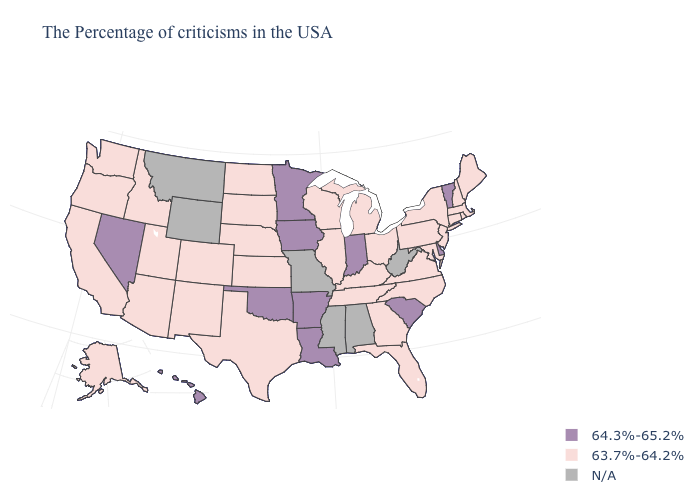Which states have the lowest value in the West?
Be succinct. Colorado, New Mexico, Utah, Arizona, Idaho, California, Washington, Oregon, Alaska. Name the states that have a value in the range N/A?
Short answer required. West Virginia, Alabama, Mississippi, Missouri, Wyoming, Montana. Name the states that have a value in the range N/A?
Quick response, please. West Virginia, Alabama, Mississippi, Missouri, Wyoming, Montana. Does South Carolina have the lowest value in the South?
Quick response, please. No. Does Indiana have the lowest value in the USA?
Give a very brief answer. No. What is the value of Wisconsin?
Answer briefly. 63.7%-64.2%. Among the states that border Wyoming , which have the lowest value?
Concise answer only. Nebraska, South Dakota, Colorado, Utah, Idaho. Among the states that border Wisconsin , does Iowa have the highest value?
Short answer required. Yes. What is the value of Kansas?
Be succinct. 63.7%-64.2%. Name the states that have a value in the range N/A?
Quick response, please. West Virginia, Alabama, Mississippi, Missouri, Wyoming, Montana. What is the value of West Virginia?
Give a very brief answer. N/A. Among the states that border Kentucky , does Indiana have the lowest value?
Answer briefly. No. Name the states that have a value in the range N/A?
Short answer required. West Virginia, Alabama, Mississippi, Missouri, Wyoming, Montana. What is the lowest value in the USA?
Be succinct. 63.7%-64.2%. What is the value of South Dakota?
Give a very brief answer. 63.7%-64.2%. 